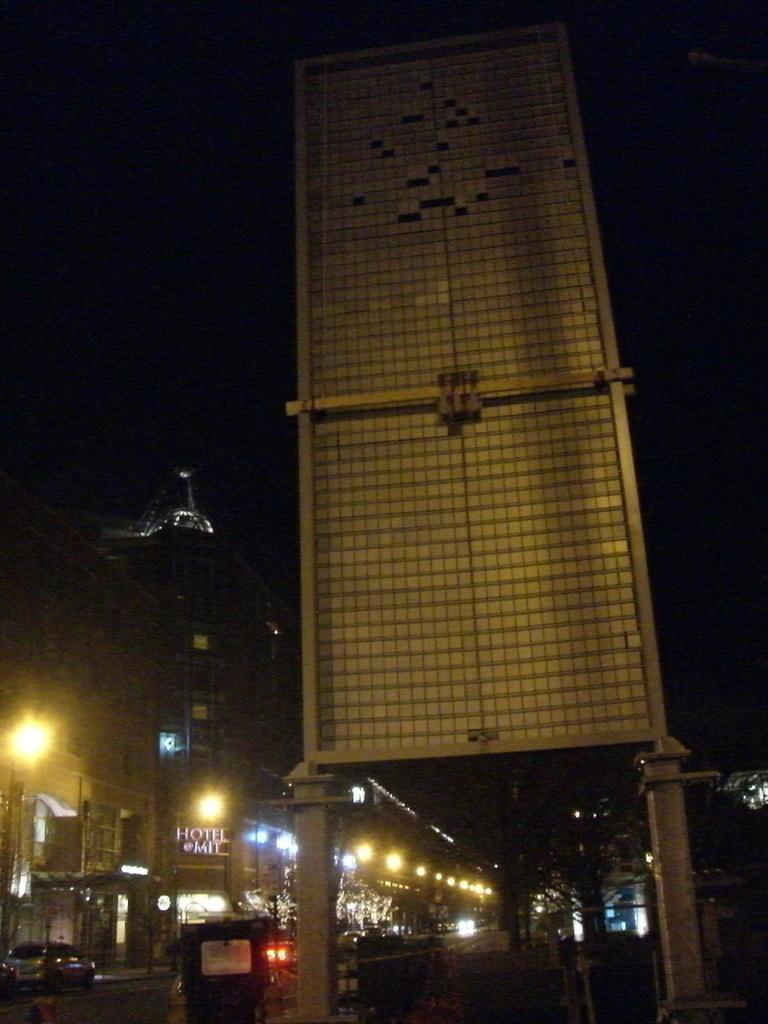Could you give a brief overview of what you see in this image? In this picture we can see vehicles on the road, here we can see lights, buildings, trees, some objects and in the background we can see it is dark. 